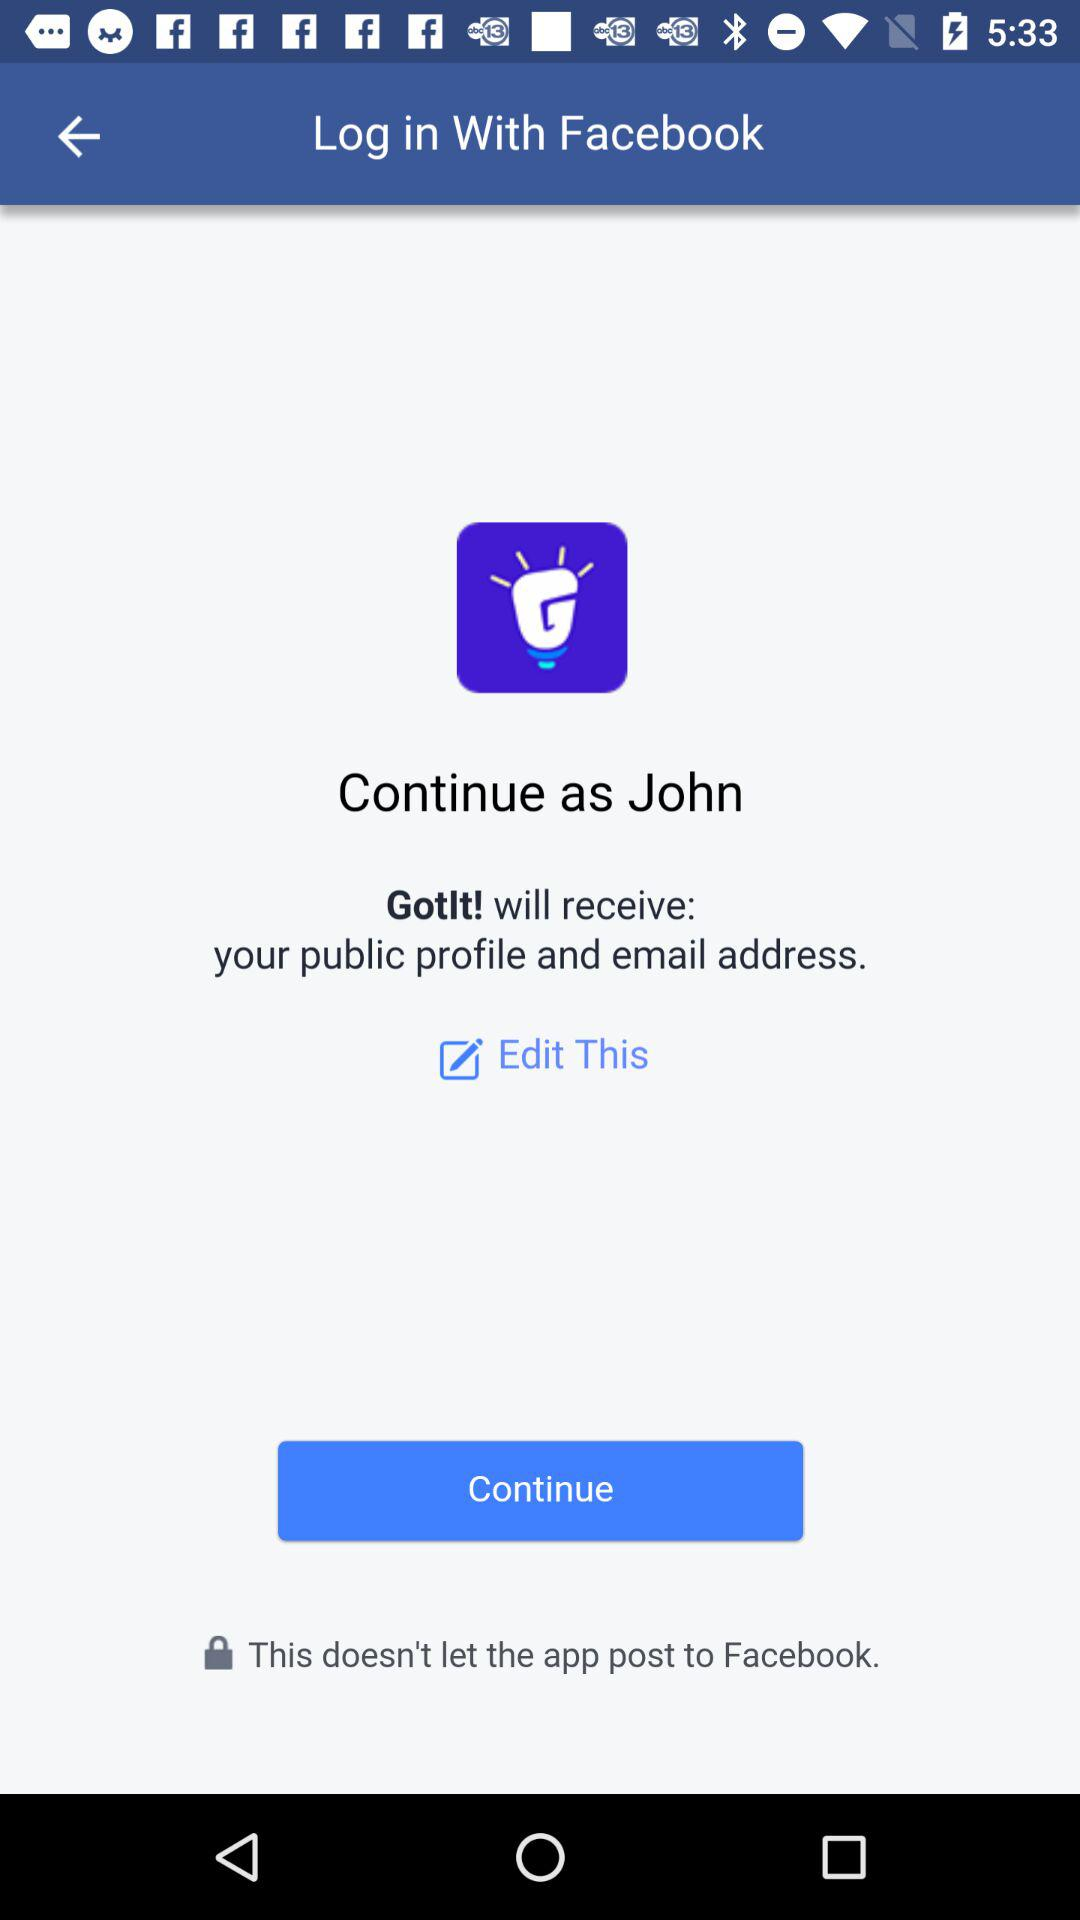What application will receive a public profile and email address? The application that will receive a public profile and an email address is "Gotlt!". 